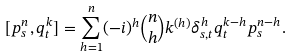Convert formula to latex. <formula><loc_0><loc_0><loc_500><loc_500>[ p ^ { n } _ { s } , q ^ { k } _ { t } ] = \sum ^ { n } _ { h = 1 } ( - i ) ^ { h } \binom { n } { h } k ^ { ( h ) } \delta ^ { h } _ { s , t } q ^ { k - h } _ { t } p ^ { n - h } _ { s } .</formula> 